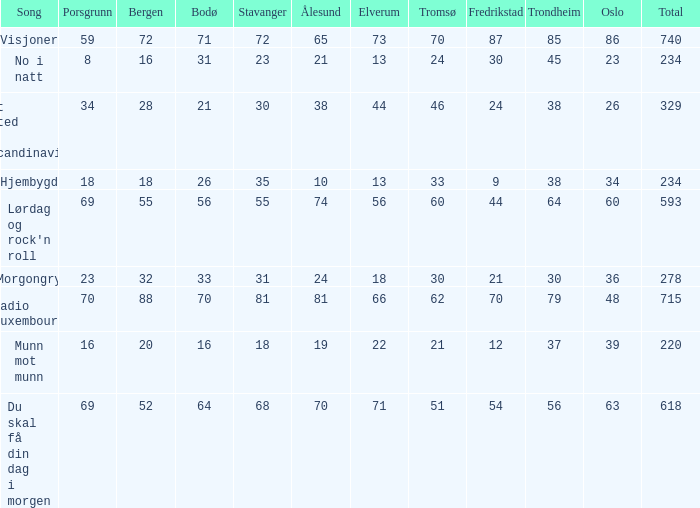When oslo is 48, what is stavanger? 81.0. 